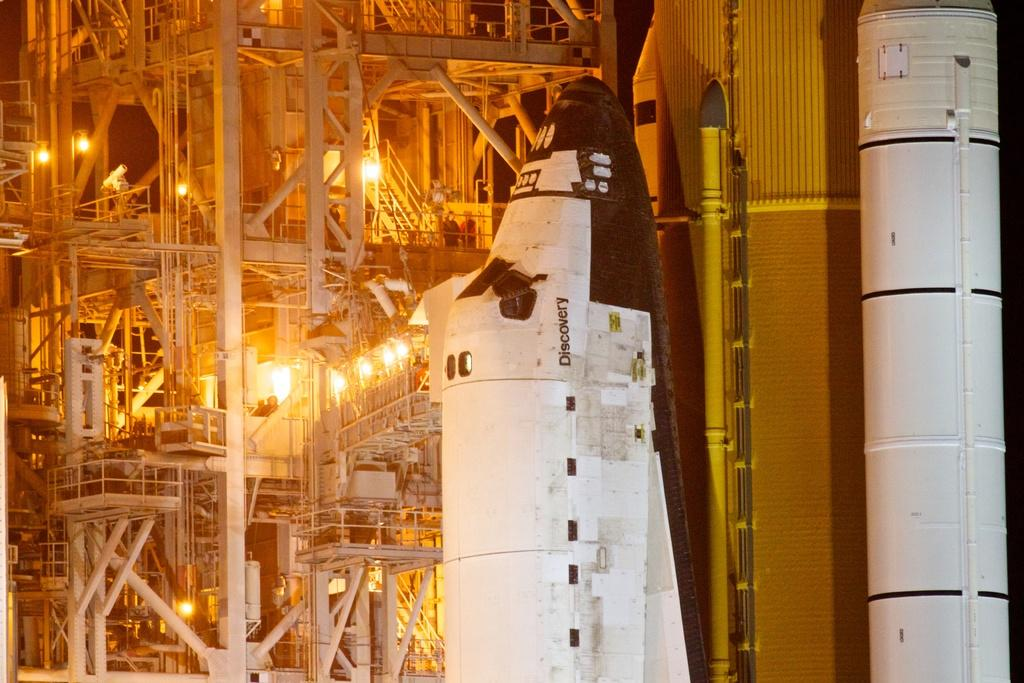What is the main subject of the image? The main subject of the image is rockets. What can be seen in the background of the image? There are lights and stairs visible in the background of the image. Are there any other objects or structures present in the image? Yes, there are rods visible in the image. How does the beggar interact with the rockets in the image? There is no beggar present in the image; it features rockets, lights, stairs, and rods. What type of wood can be seen in the image? There is no wood present in the image. 